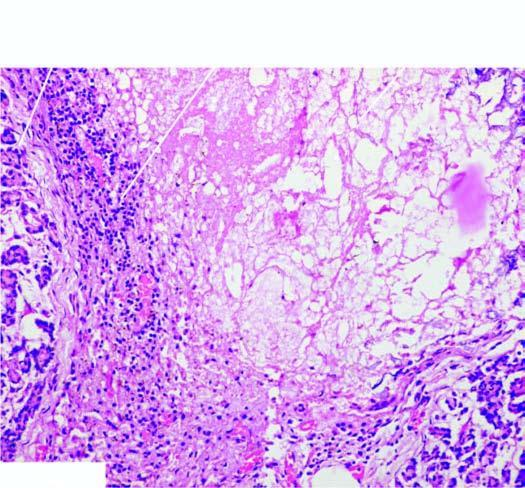s the necrotic tissue surrounded by mixed inflammatory infiltrate with granulation tissue formation?
Answer the question using a single word or phrase. Yes 